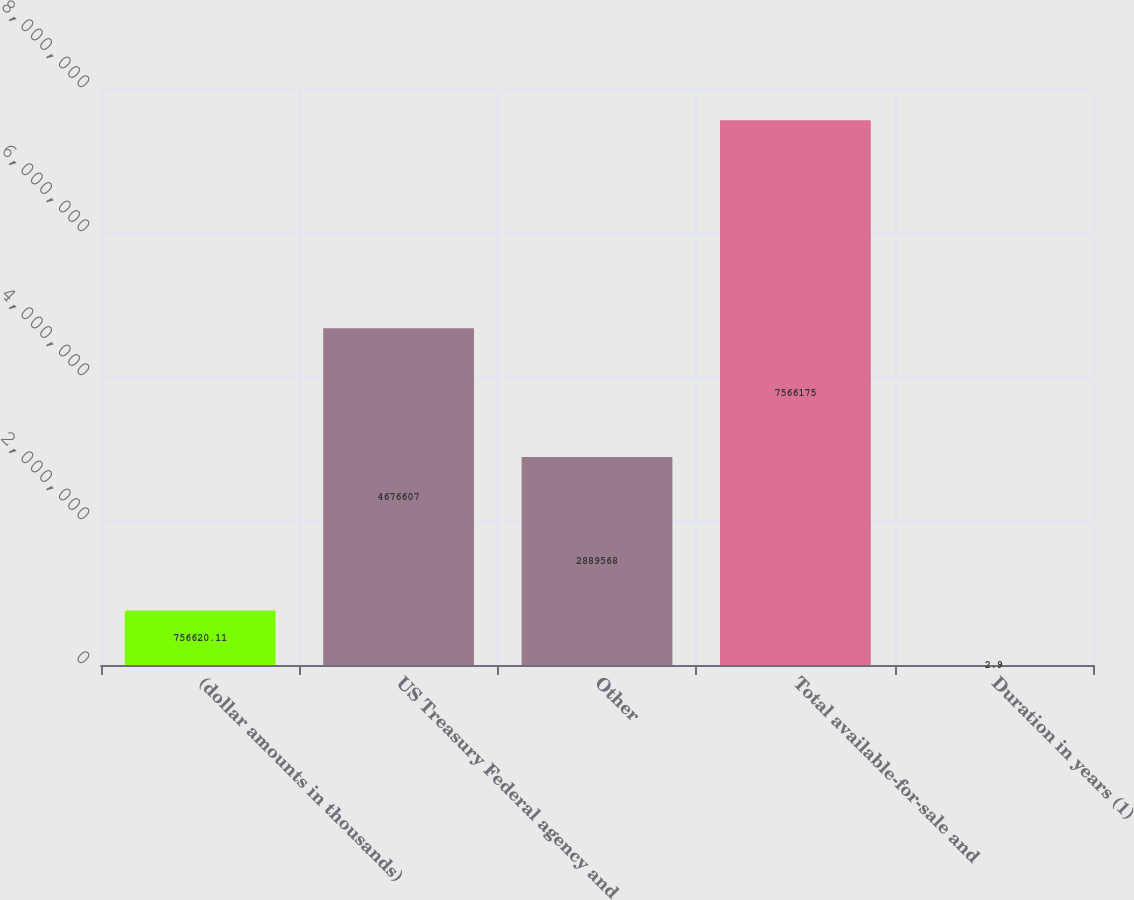Convert chart to OTSL. <chart><loc_0><loc_0><loc_500><loc_500><bar_chart><fcel>(dollar amounts in thousands)<fcel>US Treasury Federal agency and<fcel>Other<fcel>Total available-for-sale and<fcel>Duration in years (1)<nl><fcel>756620<fcel>4.67661e+06<fcel>2.88957e+06<fcel>7.56618e+06<fcel>2.9<nl></chart> 